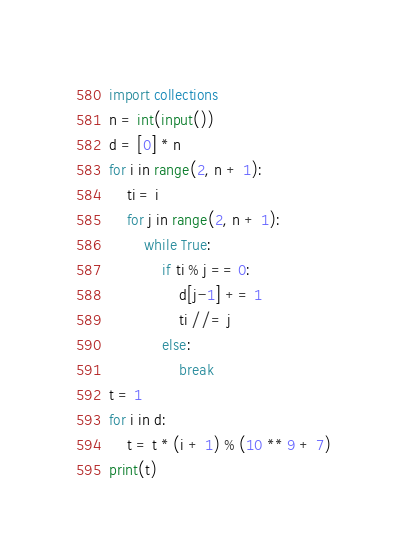Convert code to text. <code><loc_0><loc_0><loc_500><loc_500><_Python_>import collections
n = int(input())
d = [0] * n
for i in range(2, n + 1):
    ti = i
    for j in range(2, n + 1):
        while True:
            if ti % j == 0:
                d[j-1] += 1
                ti //= j
            else:
                break
t = 1
for i in d:
    t = t * (i + 1) % (10 ** 9 + 7)
print(t)
</code> 